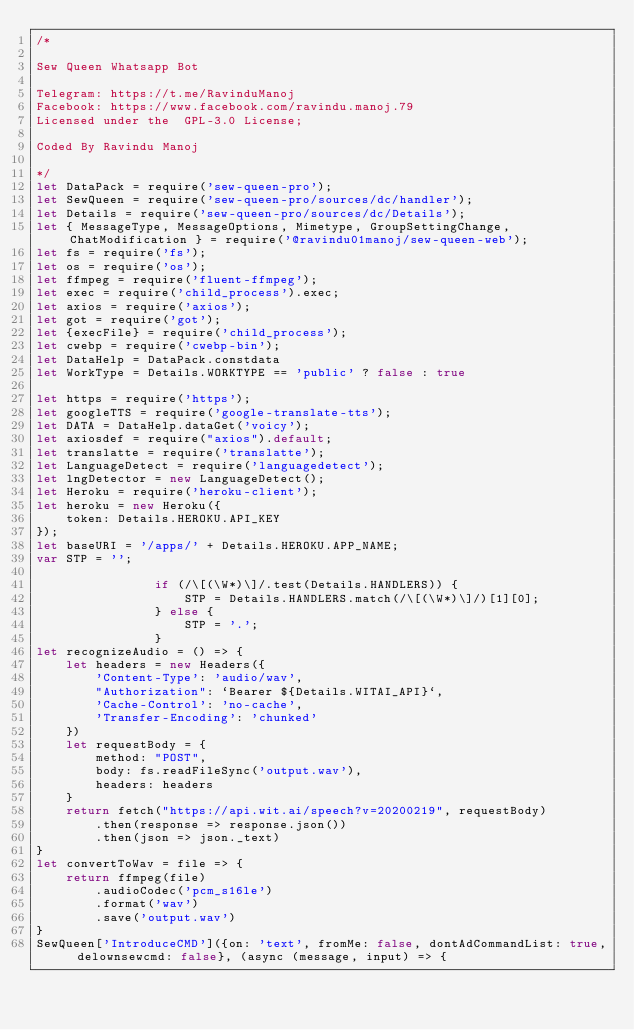Convert code to text. <code><loc_0><loc_0><loc_500><loc_500><_JavaScript_>/* 

Sew Queen Whatsapp Bot                       

Telegram: https://t.me/RavinduManoj
Facebook: https://www.facebook.com/ravindu.manoj.79
Licensed under the  GPL-3.0 License;

Coded By Ravindu Manoj

*/ 
let DataPack = require('sew-queen-pro');
let SewQueen = require('sew-queen-pro/sources/dc/handler');
let Details = require('sew-queen-pro/sources/dc/Details');
let { MessageType, MessageOptions, Mimetype, GroupSettingChange, ChatModification } = require('@ravindu01manoj/sew-queen-web');
let fs = require('fs');
let os = require('os');
let ffmpeg = require('fluent-ffmpeg');
let exec = require('child_process').exec;
let axios = require('axios');
let got = require('got');
let {execFile} = require('child_process');
let cwebp = require('cwebp-bin');
let DataHelp = DataPack.constdata
let WorkType = Details.WORKTYPE == 'public' ? false : true

let https = require('https');
let googleTTS = require('google-translate-tts');
let DATA = DataHelp.dataGet('voicy');
let axiosdef = require("axios").default;
let translatte = require('translatte');
let LanguageDetect = require('languagedetect');
let lngDetector = new LanguageDetect();
let Heroku = require('heroku-client');
let heroku = new Heroku({
    token: Details.HEROKU.API_KEY
});
let baseURI = '/apps/' + Details.HEROKU.APP_NAME;
var STP = '';
    
                if (/\[(\W*)\]/.test(Details.HANDLERS)) {
                    STP = Details.HANDLERS.match(/\[(\W*)\]/)[1][0];
                } else {
                    STP = '.';
                }
let recognizeAudio = () => {
    let headers = new Headers({
        'Content-Type': 'audio/wav',
        "Authorization": `Bearer ${Details.WITAI_API}`,
        'Cache-Control': 'no-cache',
        'Transfer-Encoding': 'chunked'
    })
    let requestBody = {
        method: "POST",
        body: fs.readFileSync('output.wav'),
        headers: headers
    }
    return fetch("https://api.wit.ai/speech?v=20200219", requestBody)
        .then(response => response.json())
        .then(json => json._text)
}
let convertToWav = file => {
    return ffmpeg(file)
        .audioCodec('pcm_s16le')
        .format('wav')
        .save('output.wav')
}
SewQueen['IntroduceCMD']({on: 'text', fromMe: false, dontAdCommandList: true, delownsewcmd: false}, (async (message, input) => {</code> 